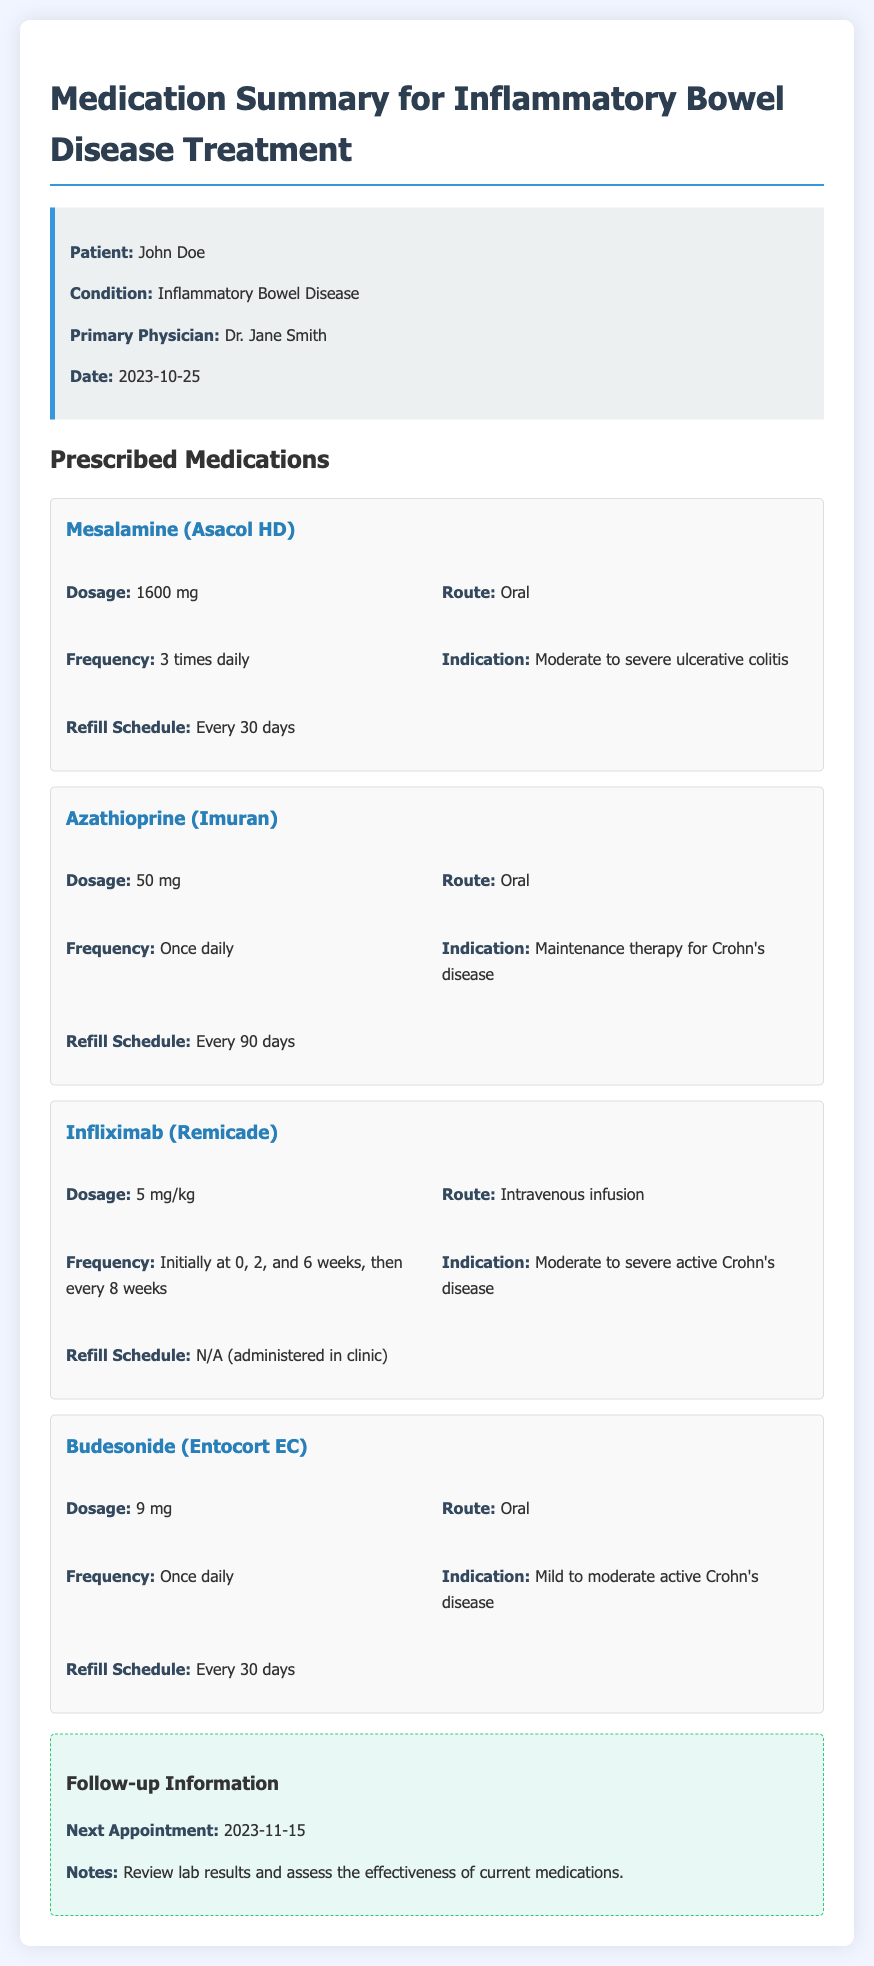What is the name of the patient? The document provides the patient's name, which is listed in the patient information section.
Answer: John Doe What is the dosage of Mesalamine? The dosage of Mesalamine is found in the medication details for that drug.
Answer: 1600 mg How often should Azathioprine be taken? The frequency for taking Azathioprine is mentioned in the medication details.
Answer: Once daily When is the next appointment scheduled? The next appointment date is stated in the follow-up information section.
Answer: 2023-11-15 What route is used for administering Infliximab? The route for Infliximab administration is specified in its medication details.
Answer: Intravenous infusion What is the refill schedule for Budesonide? The refill schedule is indicated in the medication details for Budesonide.
Answer: Every 30 days What condition is Mesalamine prescribed for? The indication for Mesalamine is mentioned in the medication details section.
Answer: Moderate to severe ulcerative colitis How many days between refills of Azathioprine? The document specifies the refill frequency for Azathioprine in the medication details.
Answer: Every 90 days What are the notes for the next appointment? The notes for the next appointment are given in the follow-up information section.
Answer: Review lab results and assess the effectiveness of current medications 